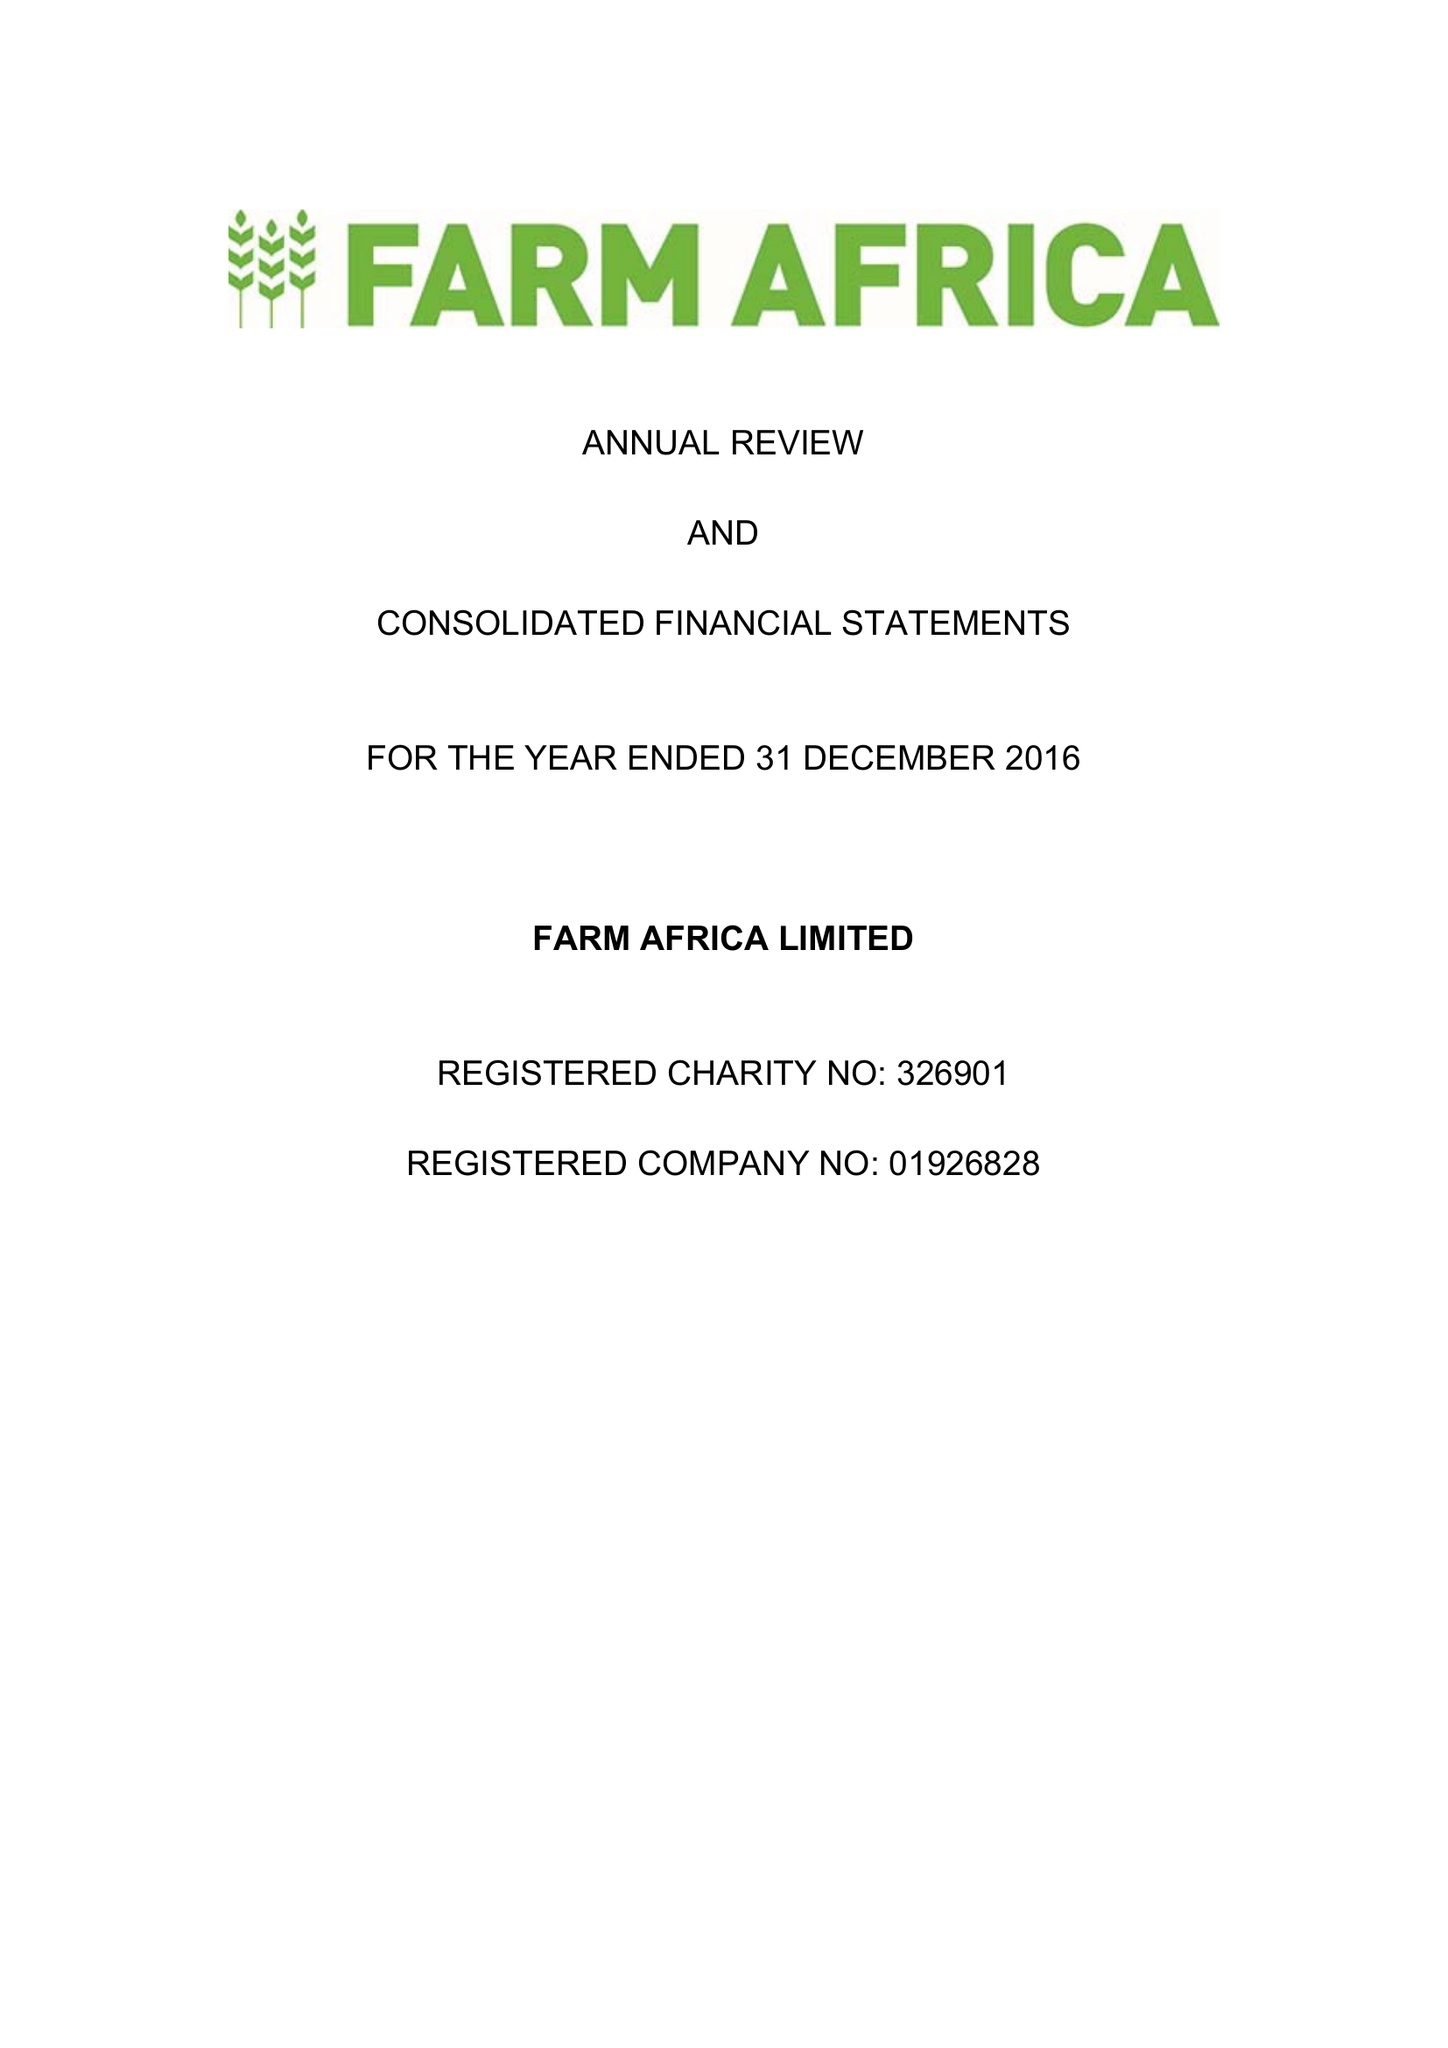What is the value for the spending_annually_in_british_pounds?
Answer the question using a single word or phrase. 16511000.00 